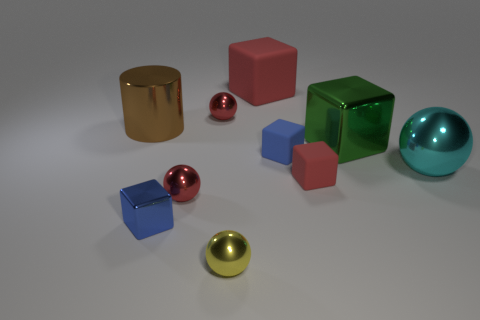Is there a pattern to how the objects are arranged? The arrangement of the objects on the surface doesn’t follow a strict pattern but appears to have a casual, almost random placement. The objects vary in size and color and are spread out, with no apparent sequence or symmetry. This scattered configuration may suggest a setting for displaying the variations in shape, color, and material without a specific narrative or order. 